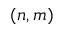<formula> <loc_0><loc_0><loc_500><loc_500>( n , m )</formula> 